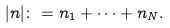Convert formula to latex. <formula><loc_0><loc_0><loc_500><loc_500>| n | \colon = n _ { 1 } + \dots + n _ { N } .</formula> 